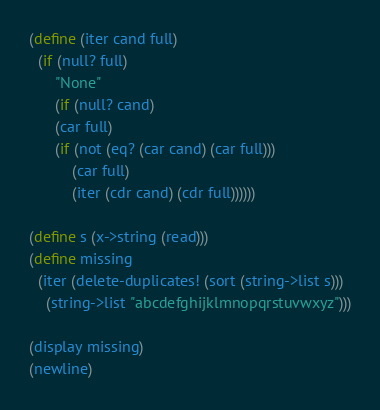<code> <loc_0><loc_0><loc_500><loc_500><_Scheme_>(define (iter cand full)
  (if (null? full)
      "None"
      (if (null? cand)
	  (car full)
	  (if (not (eq? (car cand) (car full)))
	      (car full)
	      (iter (cdr cand) (cdr full))))))

(define s (x->string (read)))
(define missing
  (iter (delete-duplicates! (sort (string->list s)))
	(string->list "abcdefghijklmnopqrstuvwxyz")))

(display missing)
(newline)    
</code> 